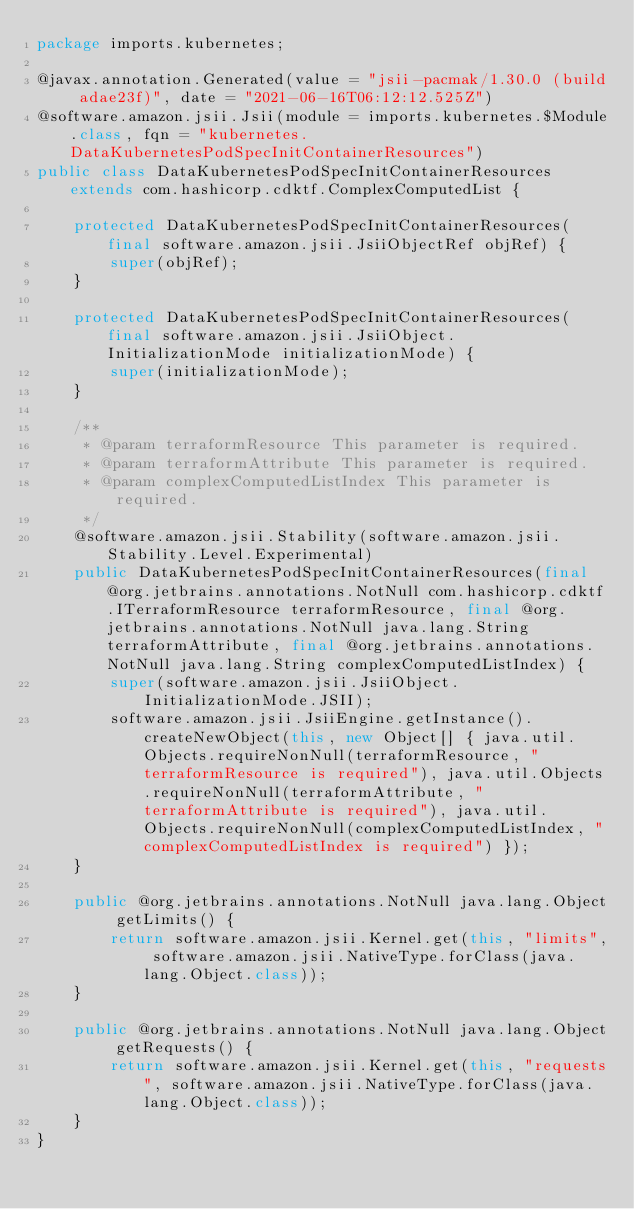<code> <loc_0><loc_0><loc_500><loc_500><_Java_>package imports.kubernetes;

@javax.annotation.Generated(value = "jsii-pacmak/1.30.0 (build adae23f)", date = "2021-06-16T06:12:12.525Z")
@software.amazon.jsii.Jsii(module = imports.kubernetes.$Module.class, fqn = "kubernetes.DataKubernetesPodSpecInitContainerResources")
public class DataKubernetesPodSpecInitContainerResources extends com.hashicorp.cdktf.ComplexComputedList {

    protected DataKubernetesPodSpecInitContainerResources(final software.amazon.jsii.JsiiObjectRef objRef) {
        super(objRef);
    }

    protected DataKubernetesPodSpecInitContainerResources(final software.amazon.jsii.JsiiObject.InitializationMode initializationMode) {
        super(initializationMode);
    }

    /**
     * @param terraformResource This parameter is required.
     * @param terraformAttribute This parameter is required.
     * @param complexComputedListIndex This parameter is required.
     */
    @software.amazon.jsii.Stability(software.amazon.jsii.Stability.Level.Experimental)
    public DataKubernetesPodSpecInitContainerResources(final @org.jetbrains.annotations.NotNull com.hashicorp.cdktf.ITerraformResource terraformResource, final @org.jetbrains.annotations.NotNull java.lang.String terraformAttribute, final @org.jetbrains.annotations.NotNull java.lang.String complexComputedListIndex) {
        super(software.amazon.jsii.JsiiObject.InitializationMode.JSII);
        software.amazon.jsii.JsiiEngine.getInstance().createNewObject(this, new Object[] { java.util.Objects.requireNonNull(terraformResource, "terraformResource is required"), java.util.Objects.requireNonNull(terraformAttribute, "terraformAttribute is required"), java.util.Objects.requireNonNull(complexComputedListIndex, "complexComputedListIndex is required") });
    }

    public @org.jetbrains.annotations.NotNull java.lang.Object getLimits() {
        return software.amazon.jsii.Kernel.get(this, "limits", software.amazon.jsii.NativeType.forClass(java.lang.Object.class));
    }

    public @org.jetbrains.annotations.NotNull java.lang.Object getRequests() {
        return software.amazon.jsii.Kernel.get(this, "requests", software.amazon.jsii.NativeType.forClass(java.lang.Object.class));
    }
}
</code> 